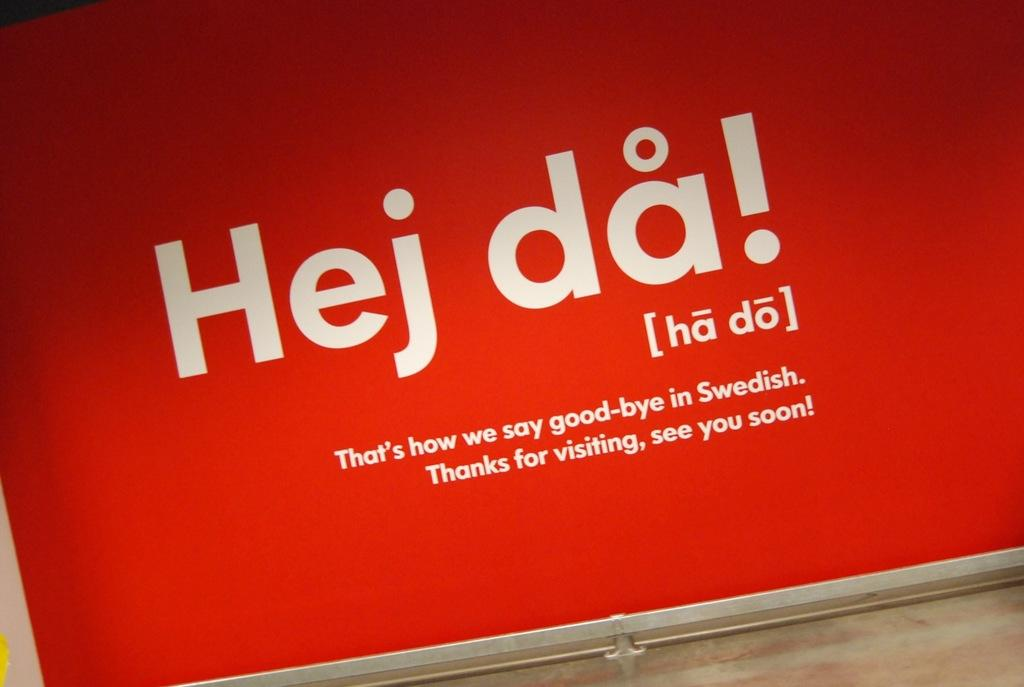<image>
Create a compact narrative representing the image presented. a red and black billboard that says thats how we say goodbye in swedish. 